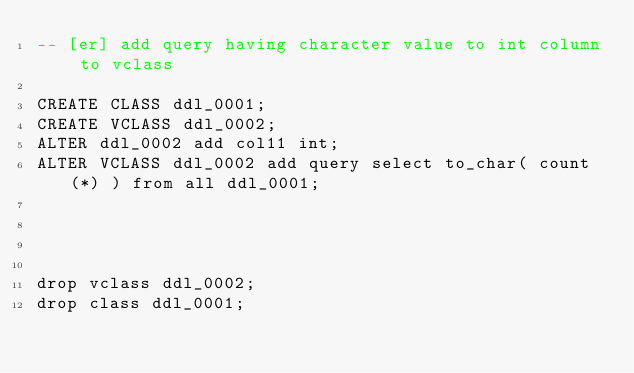<code> <loc_0><loc_0><loc_500><loc_500><_SQL_>-- [er] add query having character value to int column to vclass
 
CREATE CLASS ddl_0001;
CREATE VCLASS ddl_0002;
ALTER ddl_0002 add col11 int;
ALTER VCLASS ddl_0002 add query select to_char( count(*) ) from all ddl_0001;




drop vclass ddl_0002;
drop class ddl_0001;
</code> 